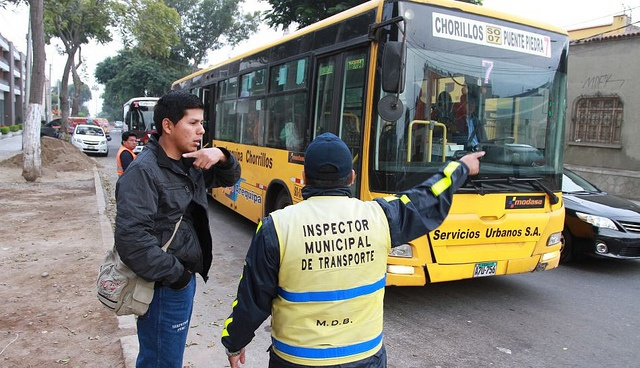Describe the objects in this image and their specific colors. I can see bus in white, black, gray, darkgray, and gold tones, people in white, black, khaki, beige, and navy tones, people in white, black, navy, gray, and darkgray tones, car in white, black, lavender, gray, and darkgray tones, and handbag in white, darkgray, gray, and black tones in this image. 